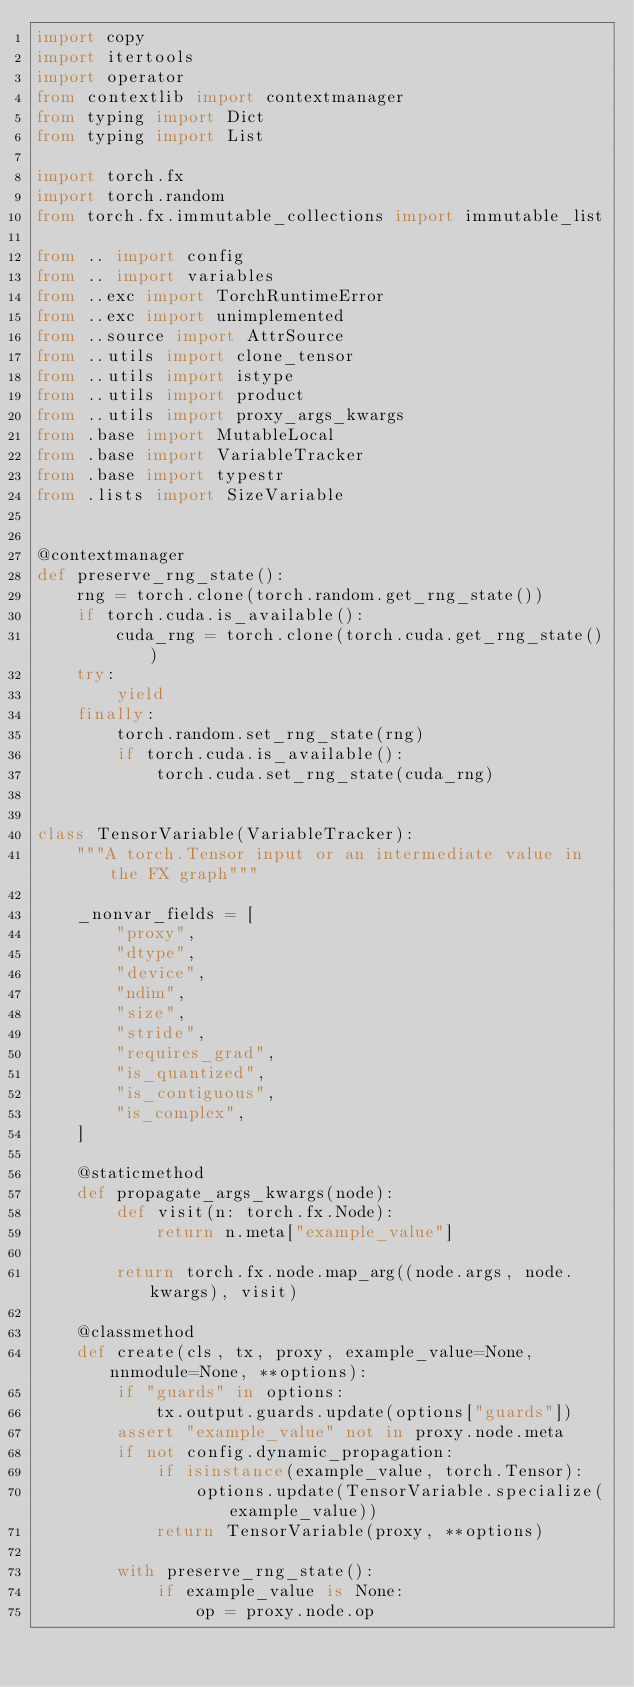Convert code to text. <code><loc_0><loc_0><loc_500><loc_500><_Python_>import copy
import itertools
import operator
from contextlib import contextmanager
from typing import Dict
from typing import List

import torch.fx
import torch.random
from torch.fx.immutable_collections import immutable_list

from .. import config
from .. import variables
from ..exc import TorchRuntimeError
from ..exc import unimplemented
from ..source import AttrSource
from ..utils import clone_tensor
from ..utils import istype
from ..utils import product
from ..utils import proxy_args_kwargs
from .base import MutableLocal
from .base import VariableTracker
from .base import typestr
from .lists import SizeVariable


@contextmanager
def preserve_rng_state():
    rng = torch.clone(torch.random.get_rng_state())
    if torch.cuda.is_available():
        cuda_rng = torch.clone(torch.cuda.get_rng_state())
    try:
        yield
    finally:
        torch.random.set_rng_state(rng)
        if torch.cuda.is_available():
            torch.cuda.set_rng_state(cuda_rng)


class TensorVariable(VariableTracker):
    """A torch.Tensor input or an intermediate value in the FX graph"""

    _nonvar_fields = [
        "proxy",
        "dtype",
        "device",
        "ndim",
        "size",
        "stride",
        "requires_grad",
        "is_quantized",
        "is_contiguous",
        "is_complex",
    ]

    @staticmethod
    def propagate_args_kwargs(node):
        def visit(n: torch.fx.Node):
            return n.meta["example_value"]

        return torch.fx.node.map_arg((node.args, node.kwargs), visit)

    @classmethod
    def create(cls, tx, proxy, example_value=None, nnmodule=None, **options):
        if "guards" in options:
            tx.output.guards.update(options["guards"])
        assert "example_value" not in proxy.node.meta
        if not config.dynamic_propagation:
            if isinstance(example_value, torch.Tensor):
                options.update(TensorVariable.specialize(example_value))
            return TensorVariable(proxy, **options)

        with preserve_rng_state():
            if example_value is None:
                op = proxy.node.op</code> 